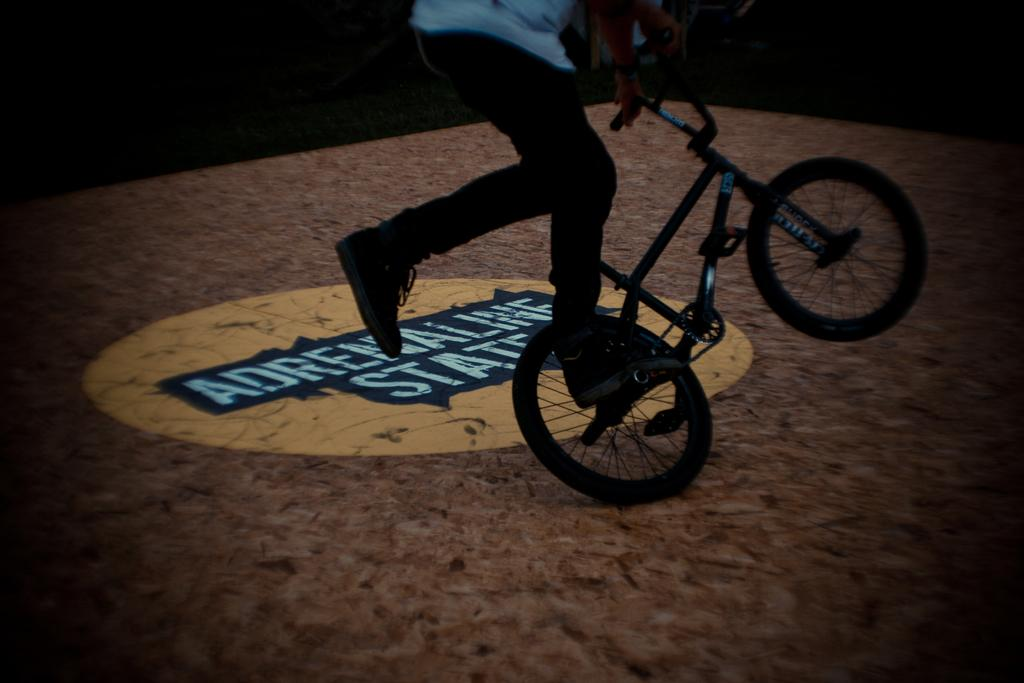What is happening in the image? There is a person in the image performing a stunt. What mode of transportation is the person using during the stunt? The person is on a bicycle during the stunt. Where is the stunt taking place? The stunt is taking place in a stadium. What type of drum can be heard playing in the background of the image? There is no drum or sound present in the image, as it is a still photograph. 